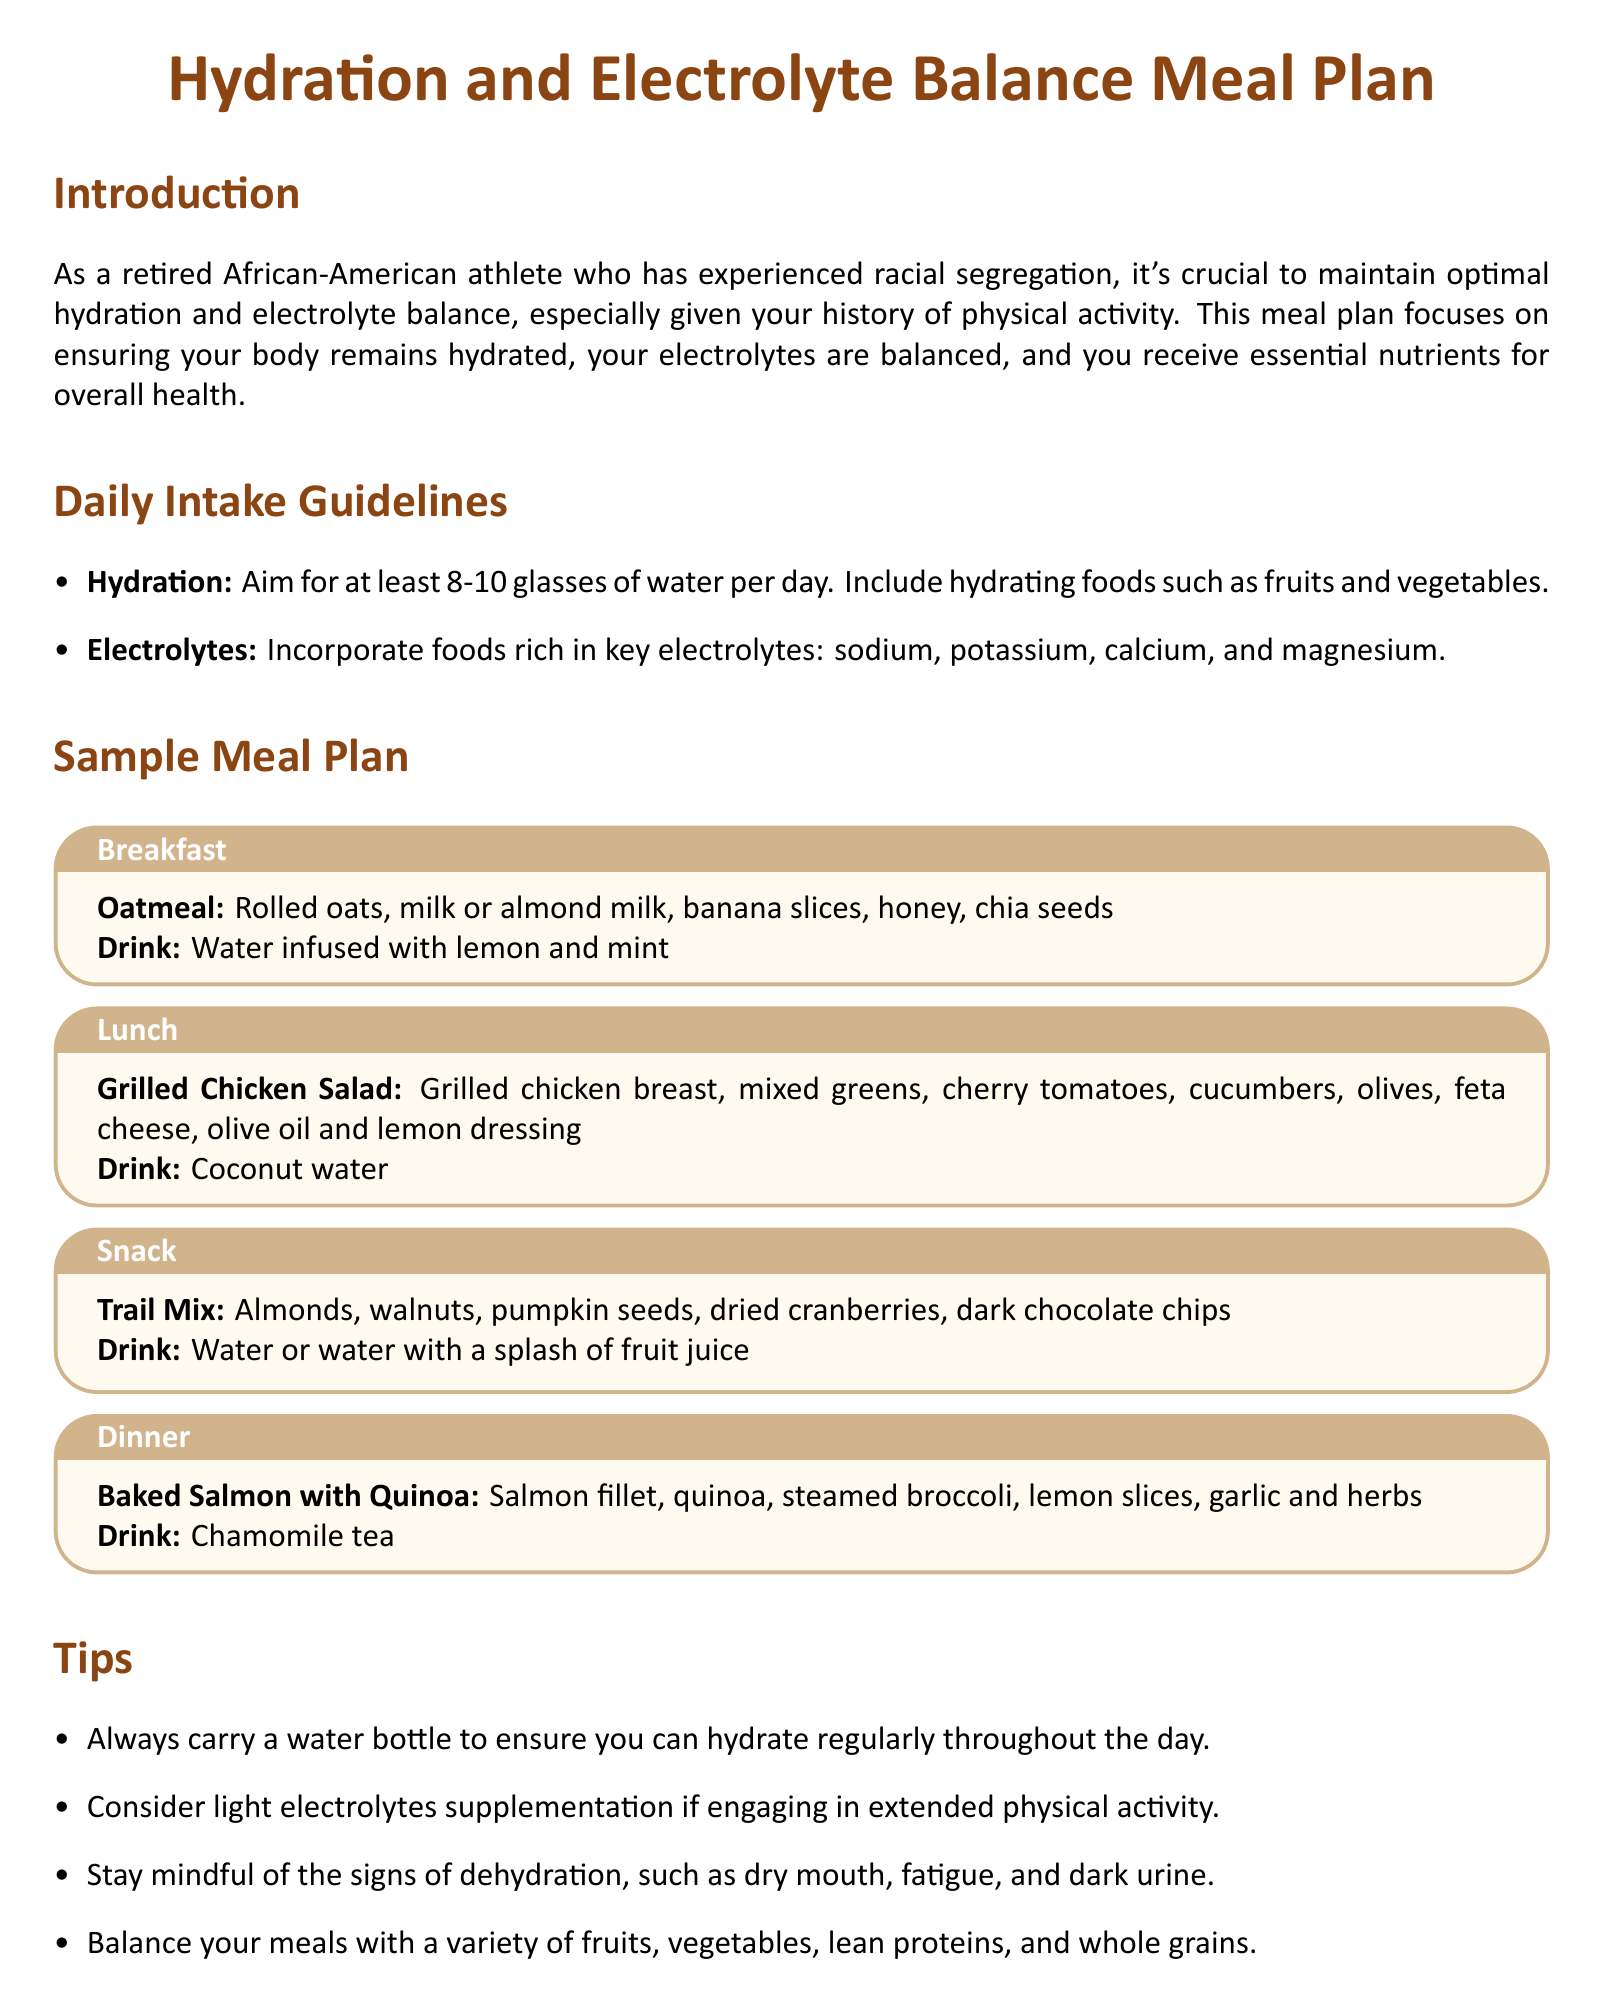What is the daily water intake recommendation? The document suggests a daily intake of at least 8-10 glasses of water.
Answer: 8-10 glasses What is included in the breakfast meal? The breakfast meal contains oatmeal, milk or almond milk, banana slices, honey, chia seeds, and water infused with lemon and mint.
Answer: Oatmeal, milk or almond milk, banana slices, honey, chia seeds, water infused with lemon and mint Which electrolyte-rich food is suggested in the lunch meal? The lunch meal includes grilled chicken breast, which is a good source of protein and can help in electrolyte balance.
Answer: Grilled chicken What drink is recommended with the dinner meal? The document specifies chamomile tea as the drink for dinner.
Answer: Chamomile tea What are two key electrolytes mentioned? Key electrolytes specified in the document include sodium and potassium.
Answer: Sodium, potassium What should you do if engaging in extended physical activity? The document suggests considering light electrolytes supplementation during extended physical activity.
Answer: Light electrolytes supplementation How can one stay hydrated throughout the day? It is advised to always carry a water bottle to hydrate regularly throughout the day.
Answer: Carry a water bottle What type of food is recommended in the snack? The snack includes trail mix, which consists of almonds, walnuts, pumpkin seeds, dried cranberries, and dark chocolate chips.
Answer: Trail mix What is a sign of dehydration mentioned? The document lists dry mouth as one of the signs of dehydration.
Answer: Dry mouth 